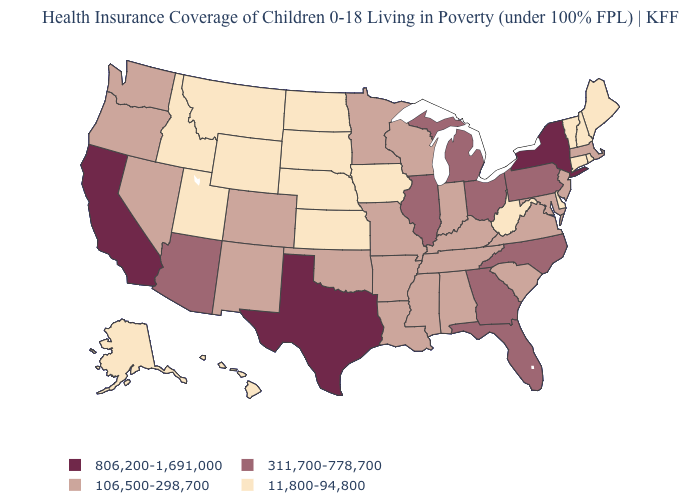Does the first symbol in the legend represent the smallest category?
Keep it brief. No. Among the states that border Arkansas , which have the highest value?
Be succinct. Texas. Name the states that have a value in the range 11,800-94,800?
Give a very brief answer. Alaska, Connecticut, Delaware, Hawaii, Idaho, Iowa, Kansas, Maine, Montana, Nebraska, New Hampshire, North Dakota, Rhode Island, South Dakota, Utah, Vermont, West Virginia, Wyoming. Name the states that have a value in the range 806,200-1,691,000?
Quick response, please. California, New York, Texas. Does the first symbol in the legend represent the smallest category?
Concise answer only. No. What is the value of New York?
Concise answer only. 806,200-1,691,000. Among the states that border Utah , which have the lowest value?
Keep it brief. Idaho, Wyoming. Does Washington have a higher value than West Virginia?
Keep it brief. Yes. Which states have the lowest value in the Northeast?
Be succinct. Connecticut, Maine, New Hampshire, Rhode Island, Vermont. Does Delaware have the lowest value in the USA?
Give a very brief answer. Yes. Does Illinois have a lower value than California?
Quick response, please. Yes. Does Montana have the same value as Oregon?
Write a very short answer. No. Among the states that border Nevada , which have the lowest value?
Concise answer only. Idaho, Utah. Does New York have the highest value in the Northeast?
Keep it brief. Yes. Among the states that border California , does Nevada have the highest value?
Concise answer only. No. 